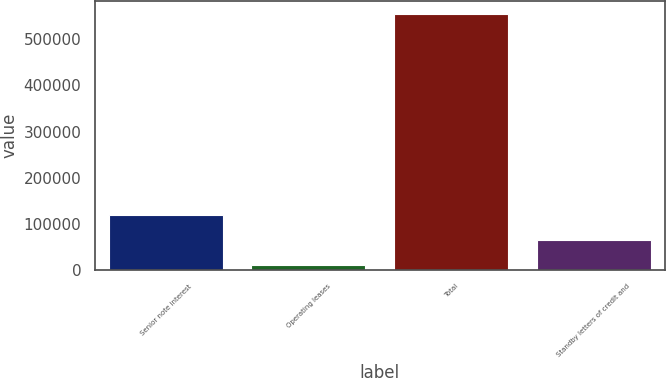<chart> <loc_0><loc_0><loc_500><loc_500><bar_chart><fcel>Senior note interest<fcel>Operating leases<fcel>Total<fcel>Standby letters of credit and<nl><fcel>120033<fcel>11049<fcel>555971<fcel>65541.2<nl></chart> 